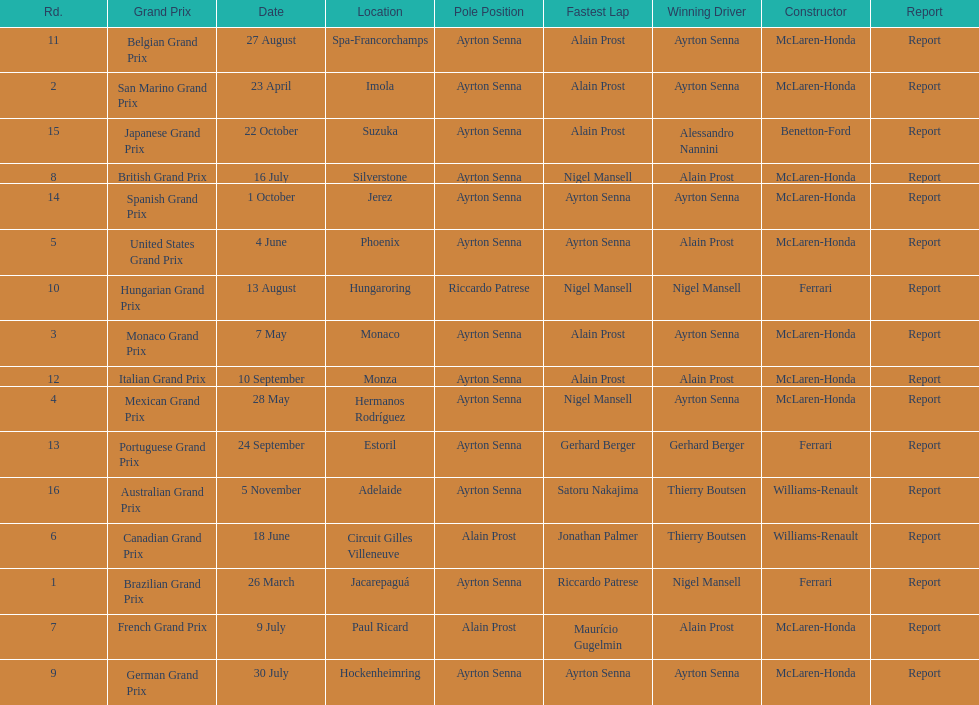How many races occurred before alain prost won a pole position? 5. 